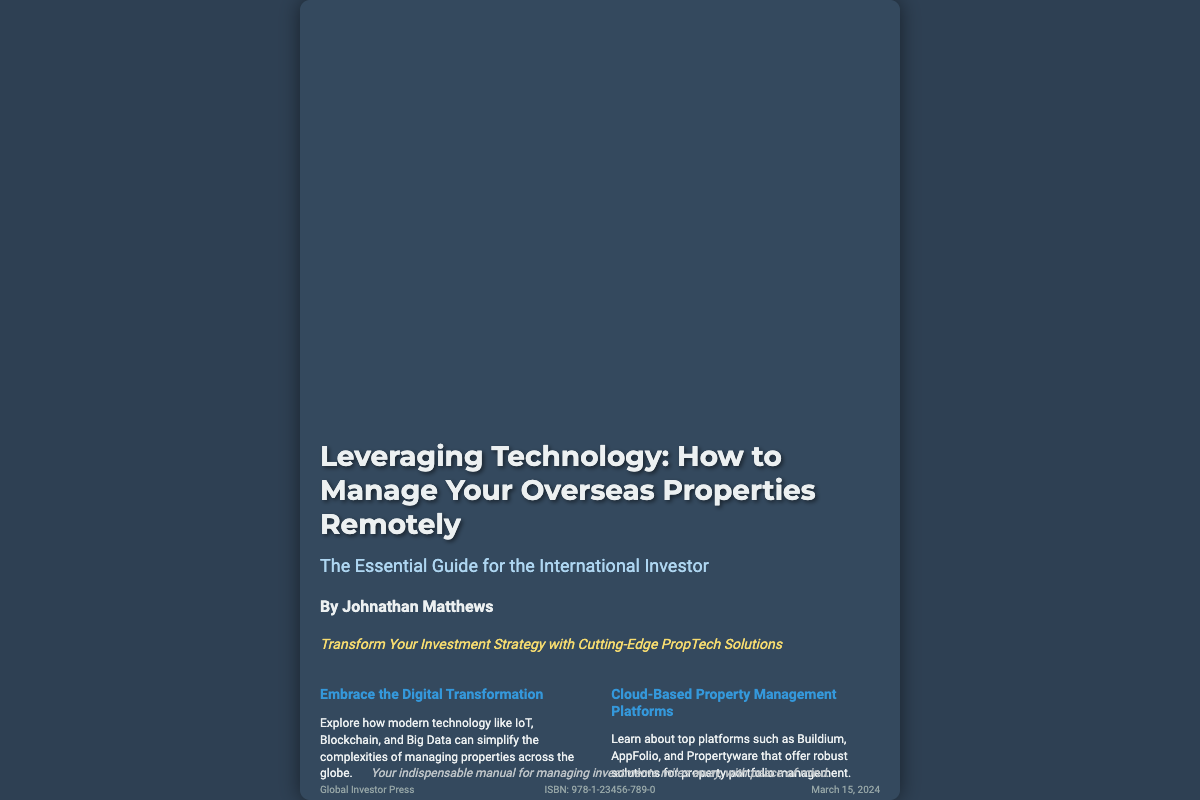What is the title of the book? The title is located at the top of the book cover, prominently displayed.
Answer: Leveraging Technology: How to Manage Your Overseas Properties Remotely Who is the author of the book? The author's name is mentioned below the title as part of the book cover information.
Answer: Johnathan Matthews What is the publisher's name? The publisher's information is found towards the bottom of the cover.
Answer: Global Investor Press When is the book published? The publication date is noted in a specific area on the book cover.
Answer: March 15, 2024 What technology is highlighted for property management? This information pertains to the main technologies discussed in the book, listed in a section.
Answer: IoT, Blockchain, and Big Data What is the tagline of the book? The tagline appears just below the author's name on the book cover.
Answer: Transform Your Investment Strategy with Cutting-Edge PropTech Solutions What type of platforms does the book discuss? The platforms are mentioned in the section addressing property management solutions.
Answer: Cloud-Based Property Management Platforms How many sections are highlighted in the content? The number of distinct sections can be counted based on the layout of the cover text.
Answer: Four What is the ISBN of the book? The ISBN is usually stated towards the bottom area of the book cover.
Answer: 978-1-23456-789-0 